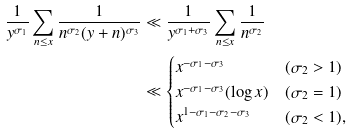Convert formula to latex. <formula><loc_0><loc_0><loc_500><loc_500>\frac { 1 } { y ^ { \sigma _ { 1 } } } \sum _ { n \leq x } \frac { 1 } { n ^ { \sigma _ { 2 } } ( y + n ) ^ { \sigma _ { 3 } } } & \ll \frac { 1 } { y ^ { \sigma _ { 1 } + \sigma _ { 3 } } } \sum _ { n \leq x } \frac { 1 } { n ^ { \sigma _ { 2 } } } \\ & \ll \begin{cases} x ^ { - \sigma _ { 1 } - \sigma _ { 3 } } & ( \sigma _ { 2 } > 1 ) \\ x ^ { - \sigma _ { 1 } - \sigma _ { 3 } } ( \log x ) & ( \sigma _ { 2 } = 1 ) \\ x ^ { 1 - \sigma _ { 1 } - \sigma _ { 2 } - \sigma _ { 3 } } & ( \sigma _ { 2 } < 1 ) , \\ \end{cases}</formula> 